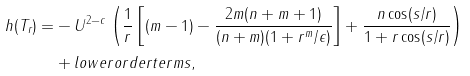<formula> <loc_0><loc_0><loc_500><loc_500>h ( T _ { r } ) = & - U ^ { 2 - c } \left ( \frac { 1 } { r } \left [ ( m - 1 ) - \frac { 2 m ( n + m + 1 ) } { ( n + m ) ( 1 + { r ^ { m } } / { \epsilon } ) } \right ] + \frac { n \cos ( s / r ) } { 1 + r \cos ( s / r ) } \right ) \\ & + l o w e r o r d e r t e r m s ,</formula> 